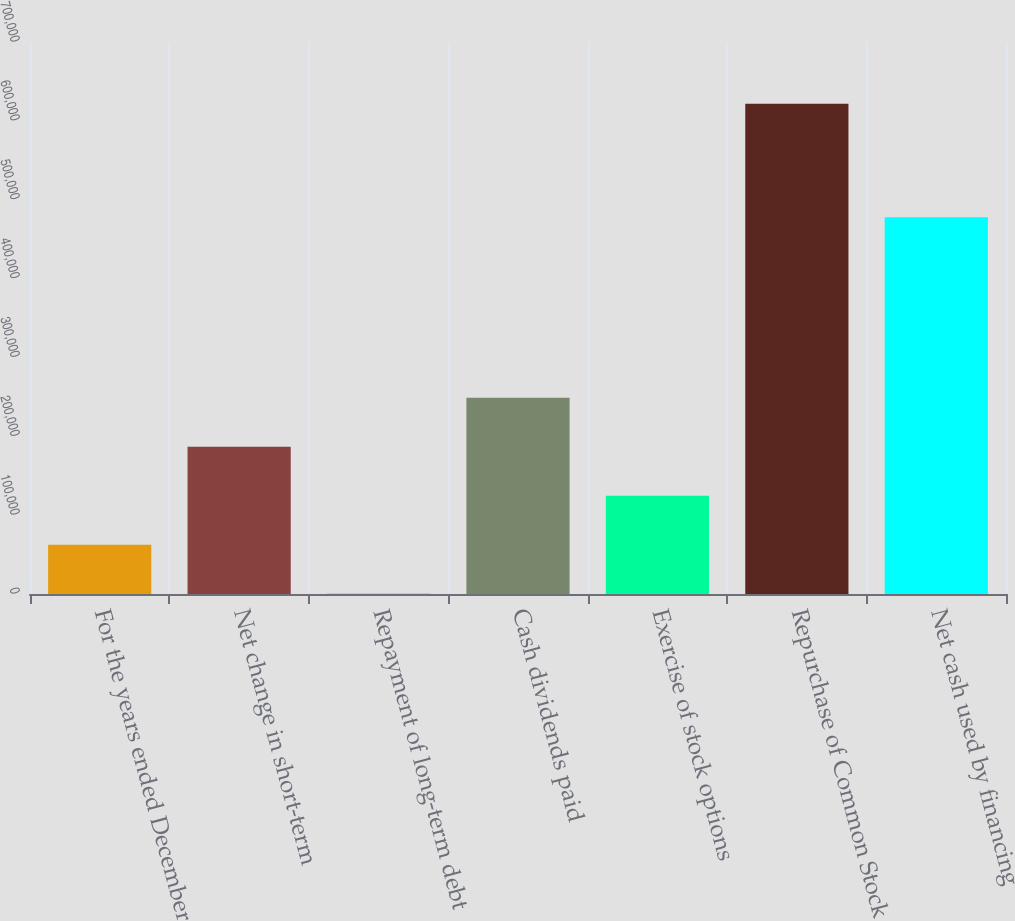Convert chart. <chart><loc_0><loc_0><loc_500><loc_500><bar_chart><fcel>For the years ended December<fcel>Net change in short-term<fcel>Repayment of long-term debt<fcel>Cash dividends paid<fcel>Exercise of stock options<fcel>Repurchase of Common Stock<fcel>Net cash used by financing<nl><fcel>62375.4<fcel>186658<fcel>234<fcel>248800<fcel>124517<fcel>621648<fcel>477723<nl></chart> 